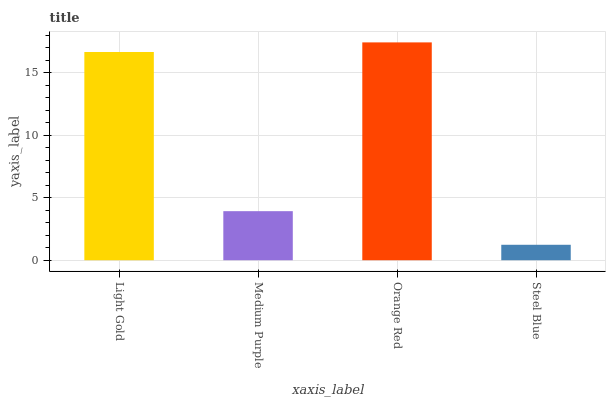Is Steel Blue the minimum?
Answer yes or no. Yes. Is Orange Red the maximum?
Answer yes or no. Yes. Is Medium Purple the minimum?
Answer yes or no. No. Is Medium Purple the maximum?
Answer yes or no. No. Is Light Gold greater than Medium Purple?
Answer yes or no. Yes. Is Medium Purple less than Light Gold?
Answer yes or no. Yes. Is Medium Purple greater than Light Gold?
Answer yes or no. No. Is Light Gold less than Medium Purple?
Answer yes or no. No. Is Light Gold the high median?
Answer yes or no. Yes. Is Medium Purple the low median?
Answer yes or no. Yes. Is Steel Blue the high median?
Answer yes or no. No. Is Steel Blue the low median?
Answer yes or no. No. 